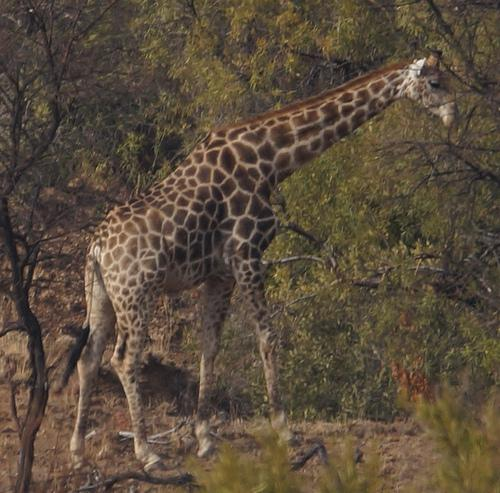Question: what type of pattern does the giraffe have?
Choices:
A. Stripes.
B. Lines.
C. Weeve.
D. Spots.
Answer with the letter. Answer: D Question: what part of the giraffe is very long?
Choices:
A. The legs.
B. The tail.
C. The body.
D. The neck.
Answer with the letter. Answer: D Question: what type of plants are visible here?
Choices:
A. Trees.
B. Bushes.
C. Flowers.
D. Vegetables.
Answer with the letter. Answer: A Question: what type of animal is in the picture?
Choices:
A. A giraffe.
B. A cow.
C. A pig.
D. A lion.
Answer with the letter. Answer: A Question: what is the giraffe eating?
Choices:
A. Grass.
B. Hay.
C. Leaves.
D. Straw.
Answer with the letter. Answer: C 